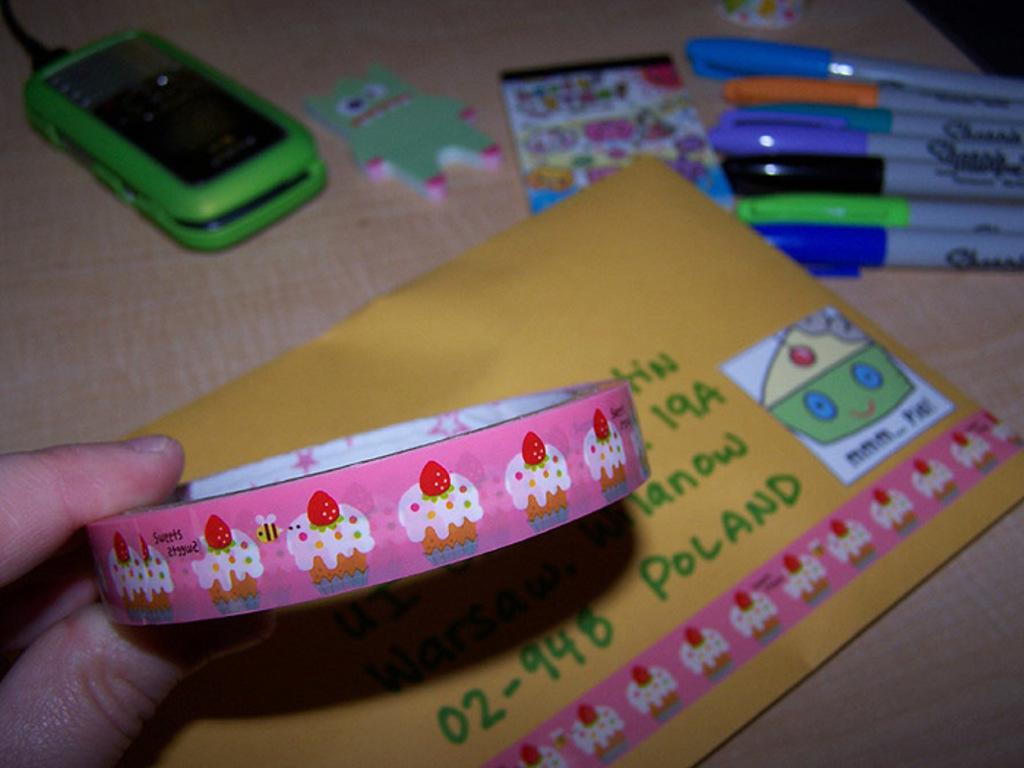To what country is this letter addressed?
Keep it short and to the point. Poland. What is the postal code shown?
Your answer should be very brief. 02-948. 